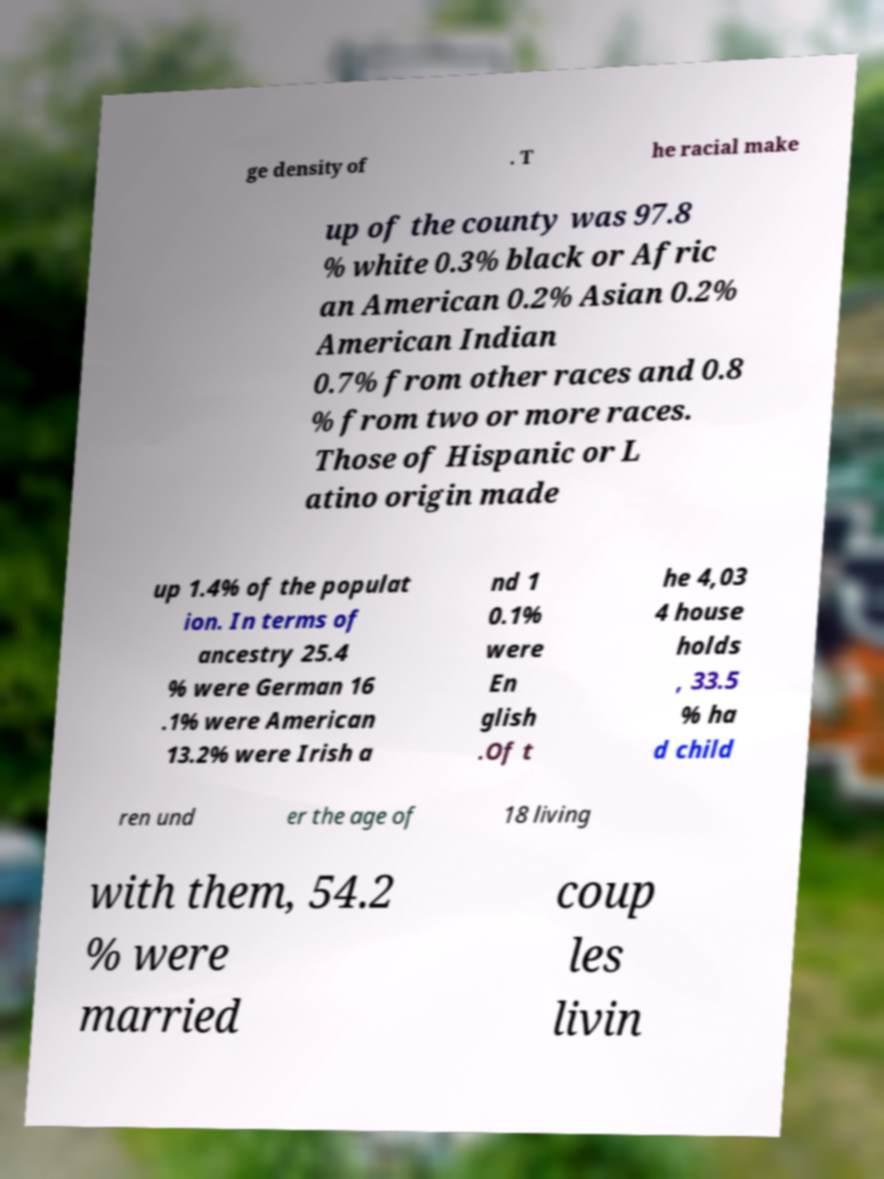Please identify and transcribe the text found in this image. ge density of . T he racial make up of the county was 97.8 % white 0.3% black or Afric an American 0.2% Asian 0.2% American Indian 0.7% from other races and 0.8 % from two or more races. Those of Hispanic or L atino origin made up 1.4% of the populat ion. In terms of ancestry 25.4 % were German 16 .1% were American 13.2% were Irish a nd 1 0.1% were En glish .Of t he 4,03 4 house holds , 33.5 % ha d child ren und er the age of 18 living with them, 54.2 % were married coup les livin 